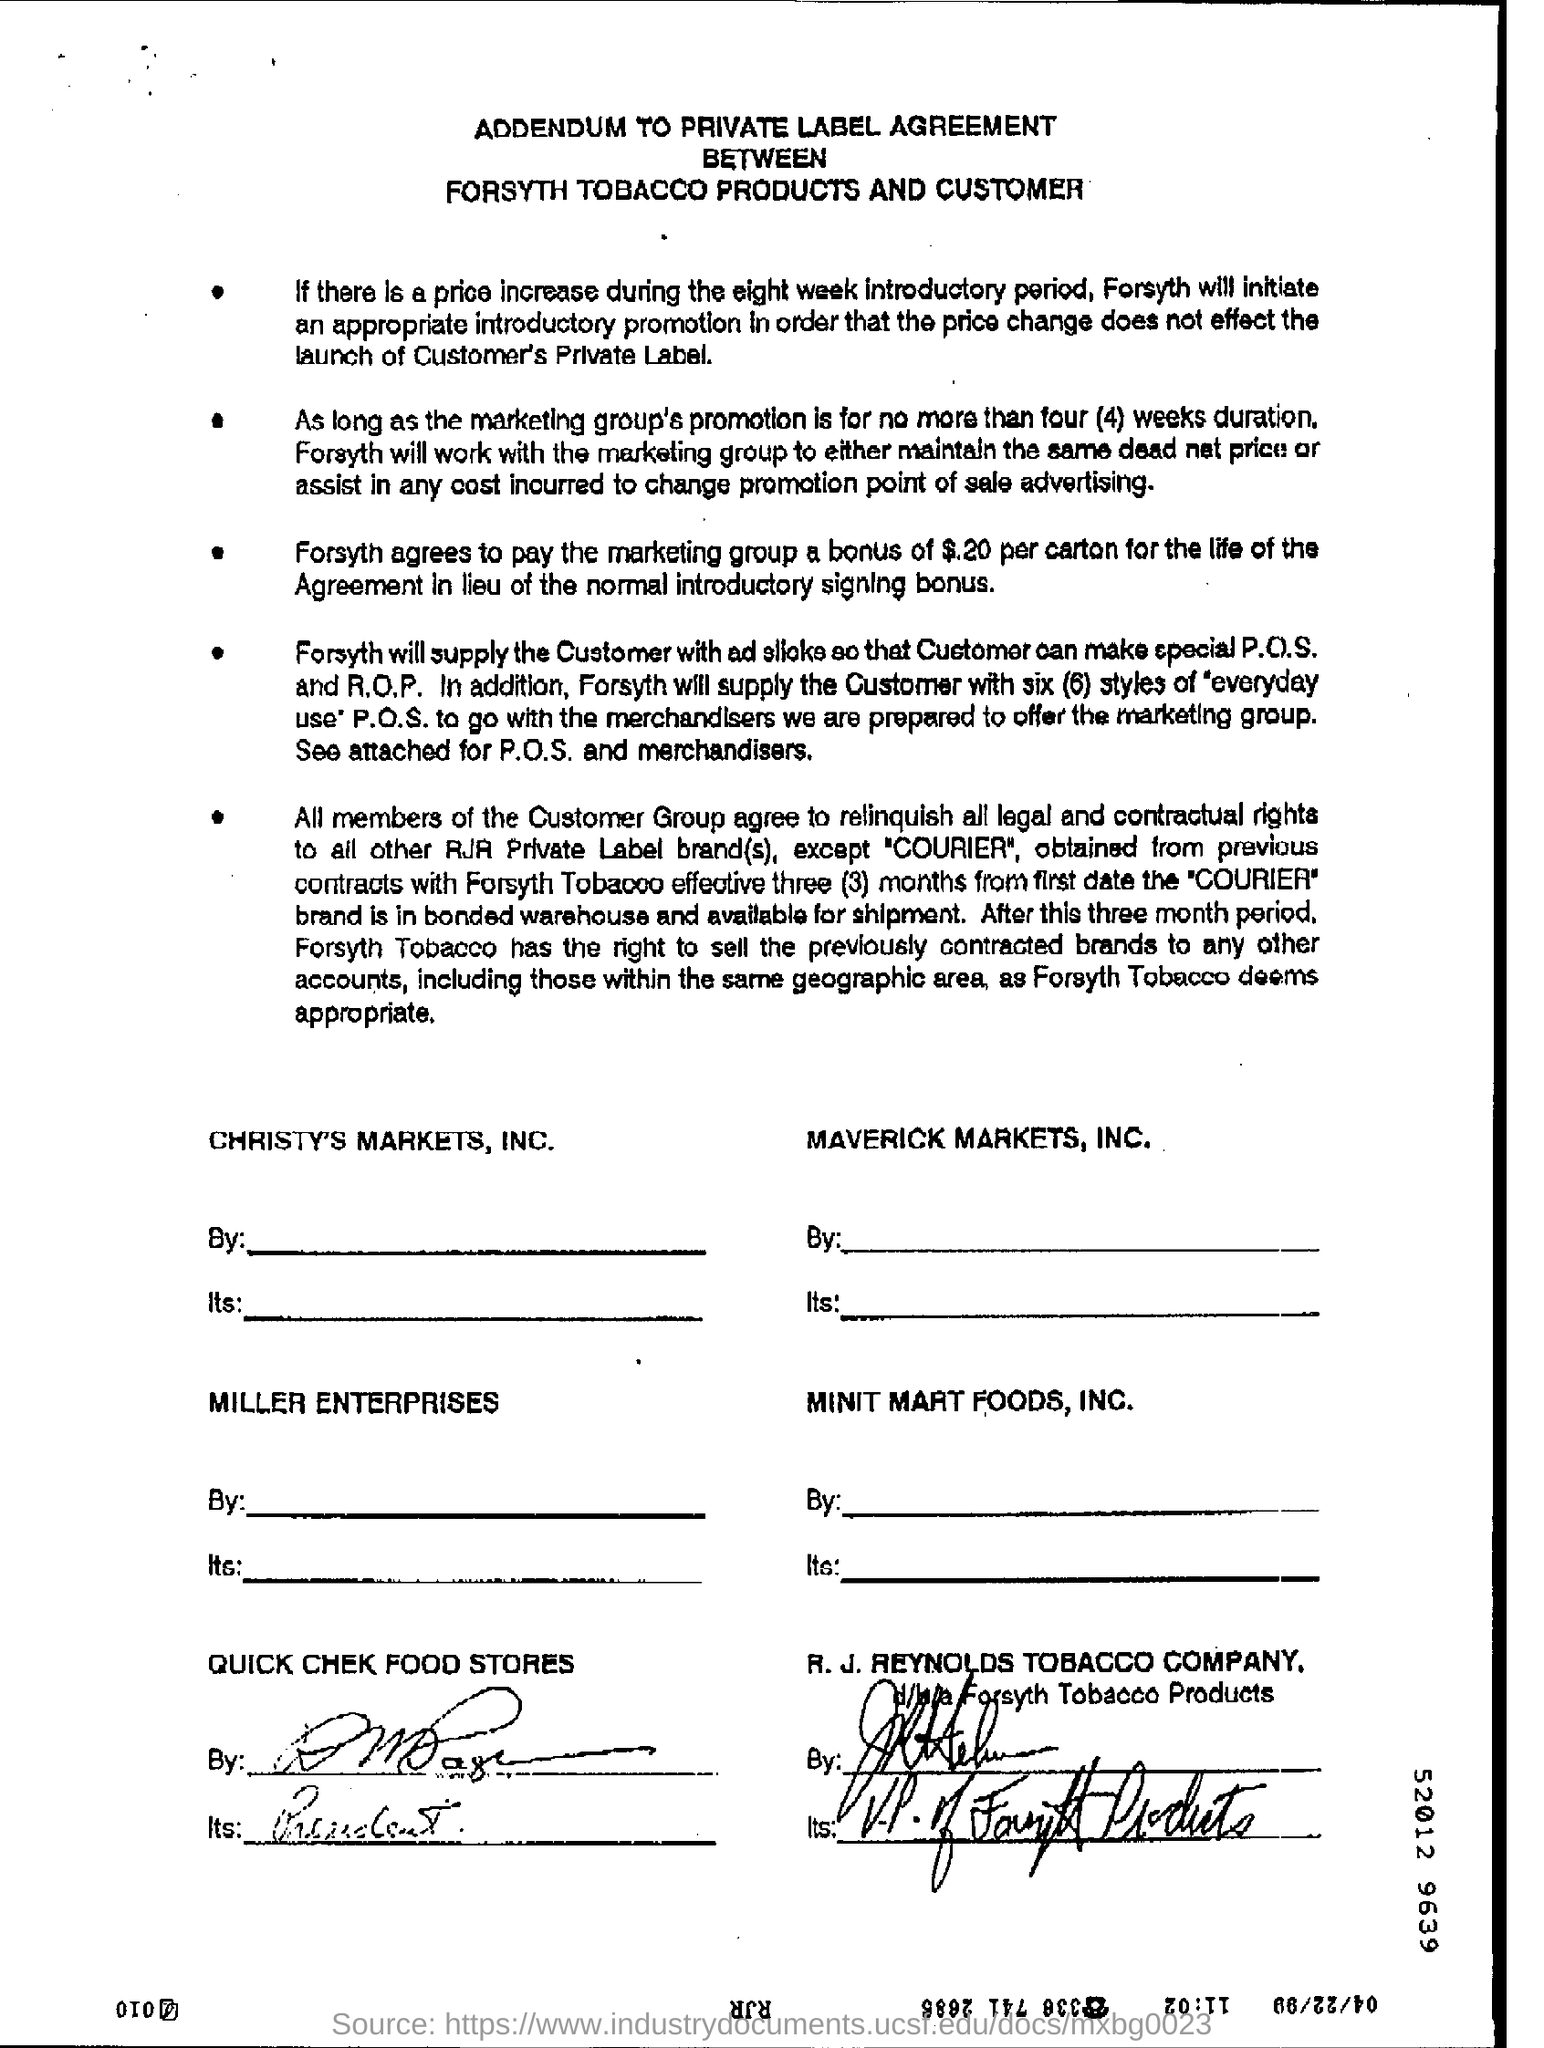Specify some key components in this picture. The promotion shall not exceed a duration of four (4) weeks. The heading of the document is 'Addendum to Private Label Agreement between Forsyth Tobacco Products and Customer.' The Forsyth will supply six (6) styles of P.O.S. systems. If there is a price increase during the eight-week introductory period, Forsyth will initiate an appropriate introductory promotion to ensure that the price change does not negatively impact the launch of the customer's private label. 